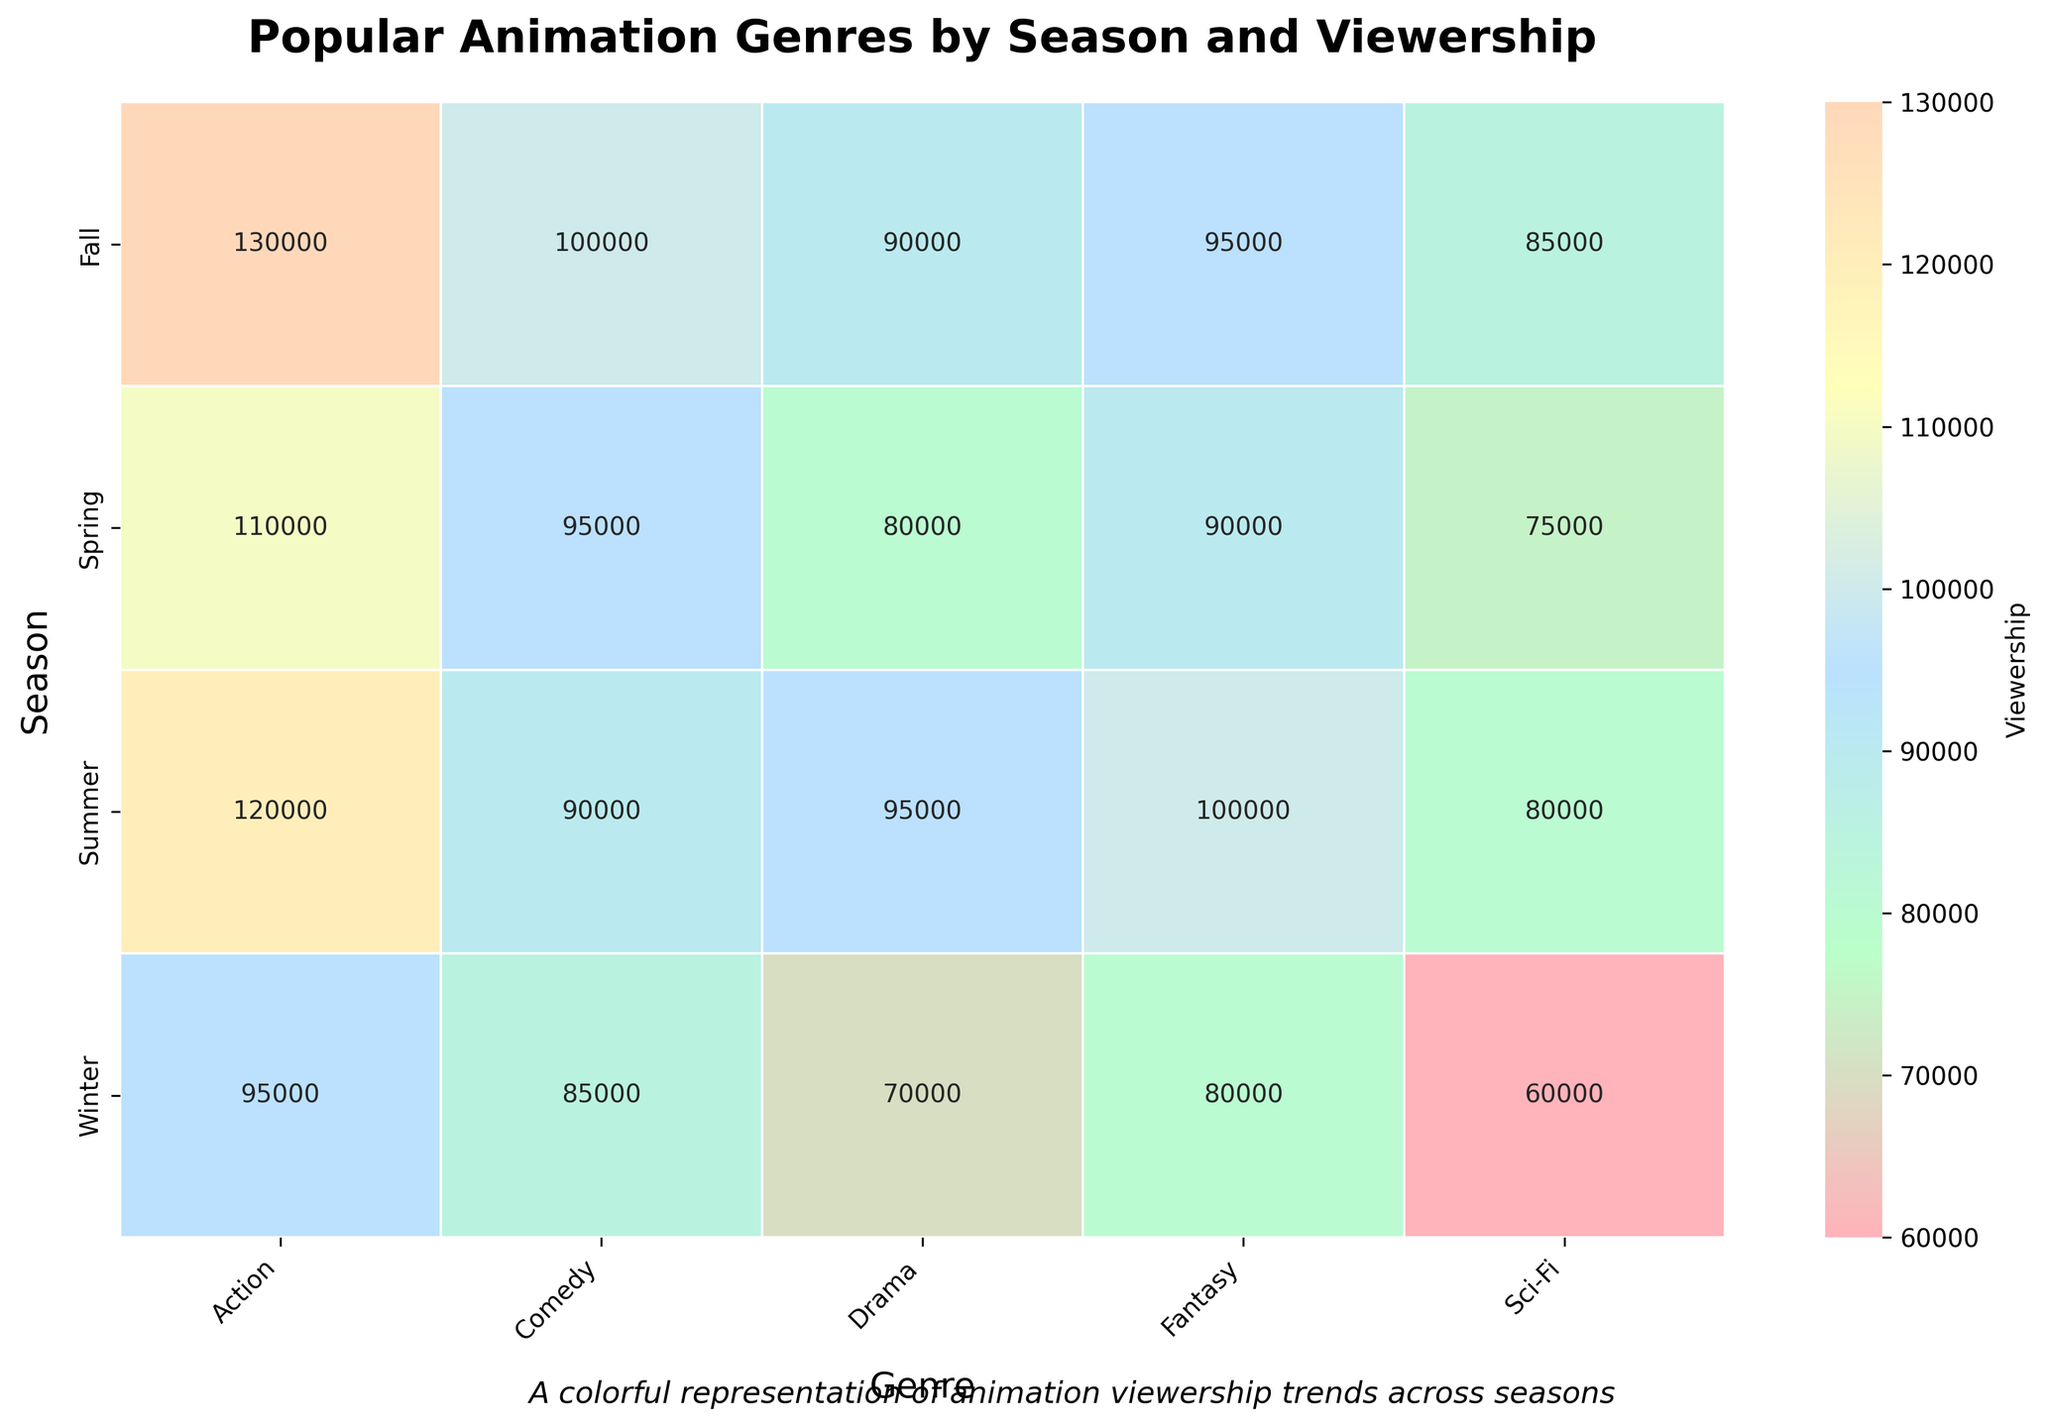What is the title of the heatmap? The title is typically placed at the top of a heatmap and is easily observable at first glance. Here, it states "Popular Animation Genres by Season and Viewership."
Answer: Popular Animation Genres by Season and Viewership Which season has the highest viewership for the Action genre? To find this, look at the Action column and identify the season row with the highest numeric value. Fall has the highest Action viewership at 130,000.
Answer: Fall In which season is the viewership for Comedy lowest? Check the Comedy column, and compare all the values. The lowest value of 85,000 is found in Winter.
Answer: Winter What genre has the highest viewership in Summer? Within the Summer row, compare the viewership numbers across all genres. Action has the highest viewership of 120,000 in Summer.
Answer: Action How does Sci-Fi viewership in Spring compare to Winter? Locate the Sci-Fi column and compare the values for Spring (75,000) and Winter (60,000). 75,000 (Spring) is higher than 60,000 (Winter).
Answer: 75,000 (Spring) is higher than 60,000 (Winter) What is the total viewership across all genres in Fall? Add up all the viewership numbers in the Fall row: Fantasy (95,000) + Action (130,000) + Comedy (100,000) + Sci-Fi (85,000) + Drama (90,000). The total is 500,000.
Answer: 500,000 Which seasons have higher Action viewership than Fantasy viewership? Compare the values of Action and Fantasy across all seasons: Winter (95,000 > 80,000), Spring (110,000 > 90,000), Summer (120,000 > 100,000), Fall (130,000 > 95,000). All seasons meet the criteria.
Answer: Winter, Spring, Summer, Fall What is the average viewership for Drama across all seasons? Add up the Drama viewership across each season and divide by the number of seasons: (70,000 + 80,000 + 95,000 + 90,000) / 4 is 83,750.
Answer: 83,750 For which genre is the viewership most consistent across seasons? Calculate the range (max - min) for each genre: 
Fantasy (100,000 - 80,000 = 20,000)
Action (130,000 - 95,000 = 35,000)
Comedy (100,000 - 85,000 = 15,000)
Sci-Fi (85,000 - 60,000 = 25,000)
Drama (95,000 - 70,000 = 25,000)
Comedy has the smallest range (15,000), indicating the most consistency.
Answer: Comedy 